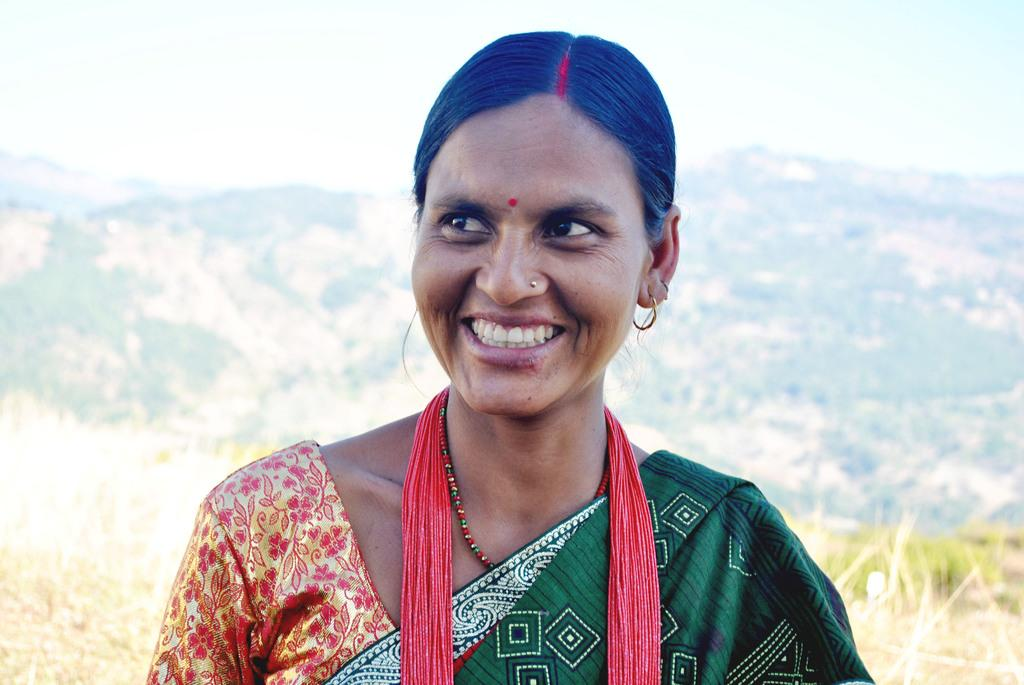Who is present in the image? There is a woman in the image. What type of natural environment can be seen in the background? There is grass, mountains, and the sky visible in the background of the image. How many spiders can be seen crawling on the woman's face in the image? There are no spiders present in the image; it only features a woman and the natural environment in the background. 